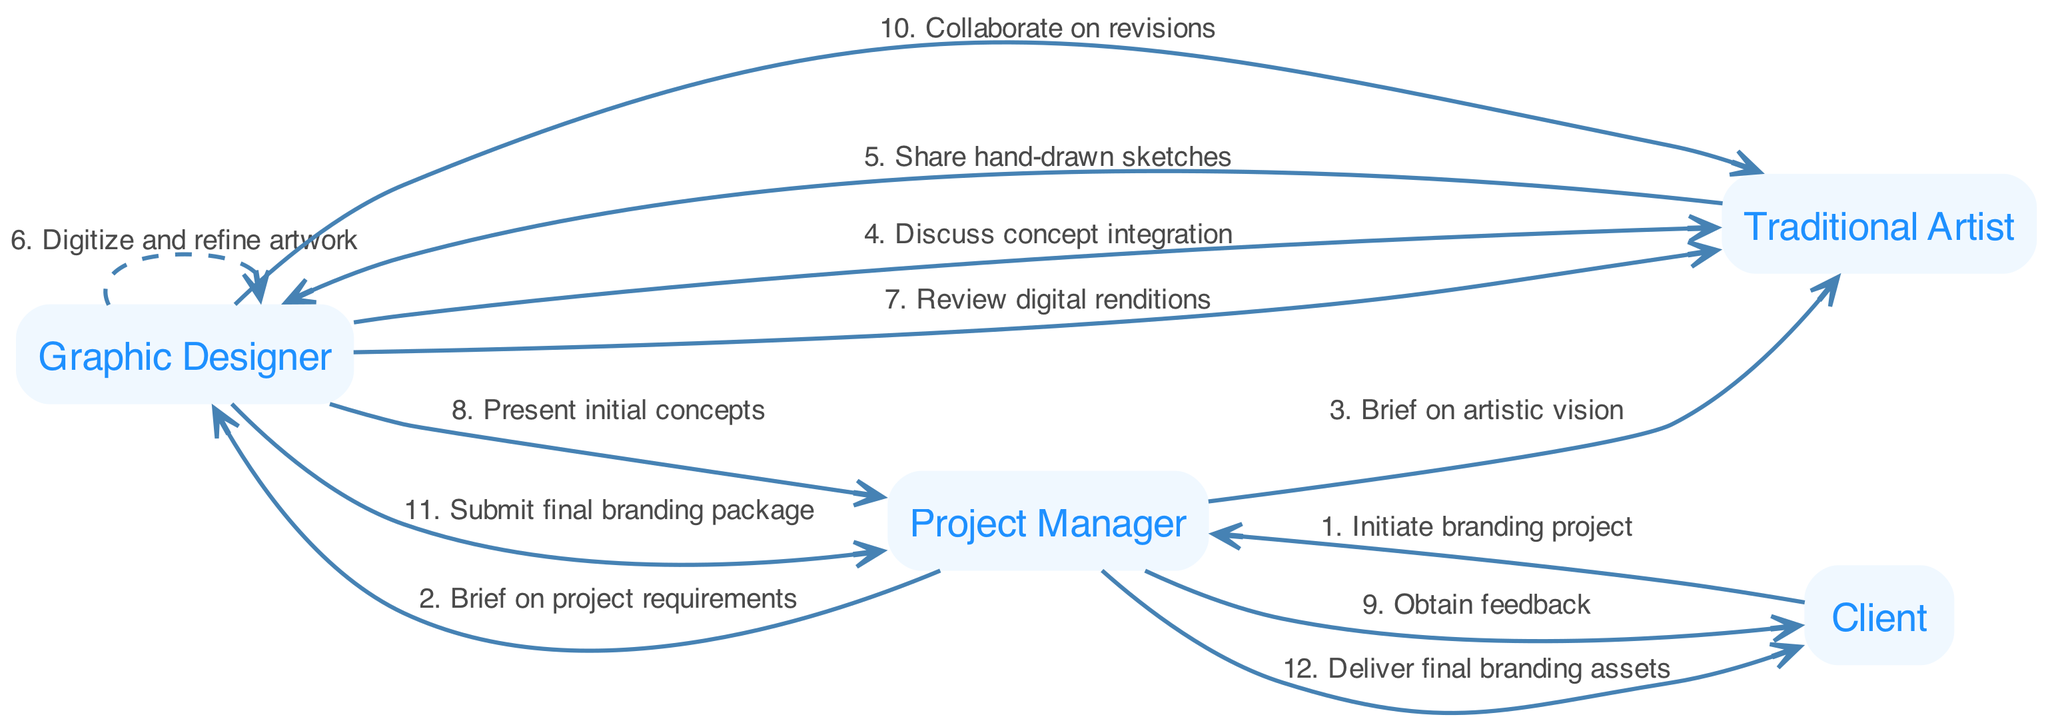What is the total number of actors in the diagram? The diagram lists four actors: Graphic Designer, Traditional Artist, Client, and Project Manager. By counting these distinct roles, we find that the total is four.
Answer: 4 Which actor is responsible for obtaining feedback from the Client? The Project Manager communicates with the Client to obtain feedback after presenting initial concepts. This step shows the Project Manager's mediating role.
Answer: Project Manager What message is exchanged between the Graphic Designer and Traditional Artist after sharing sketches? After sharing hand-drawn sketches, the Graphic Designer asks the Traditional Artist to review the digital renditions to ensure the concepts align. The direct connection highlights the collaboration.
Answer: Review digital renditions How many messages are sent from the Client to the Project Manager throughout the workflow? The Client initiates the branding project and later receives the final branding assets. Thus, there are two messages originating from the Client to the Project Manager in the sequence.
Answer: 2 Describe the flow of messages that lead to the submission of the final branding package. The final branding package submission starts with discussions and reviews between the Graphic Designer and Traditional Artist, aligns with feedback from the Client, and culminates with the Graphic Designer submitting to the Project Manager, marking the completion of the design cycle. This indicates the collaborative effort in reaching the final stage.
Answer: Discussion, review, submission Which two actors are primarily involved in the conceptual phase of the project? During the conceptual phase, the Graphic Designer and Traditional Artist communicate and share ideas to integrate concepts creatively. This exchange is critical to establish the project's visual direction.
Answer: Graphic Designer and Traditional Artist What type of relationship does the message describing the review of digital renditions indicate? The message between the Graphic Designer and Traditional Artist signifies a collaborative relationship, showcasing their team effort to refine ideas and artwork collaboratively in the project.
Answer: Collaborative relationship Identify the sequence number of the message where the Project Manager informs the Client about delivering final branding assets. This message comes at the end when the Project Manager delivers the final branding assets to the Client, marking it as the final step in the sequence of messages, specifically the twelfth.
Answer: 12 